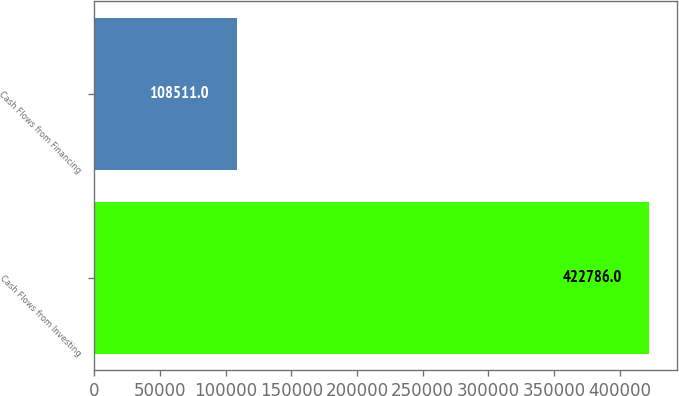<chart> <loc_0><loc_0><loc_500><loc_500><bar_chart><fcel>Cash Flows from Investing<fcel>Cash Flows from Financing<nl><fcel>422786<fcel>108511<nl></chart> 